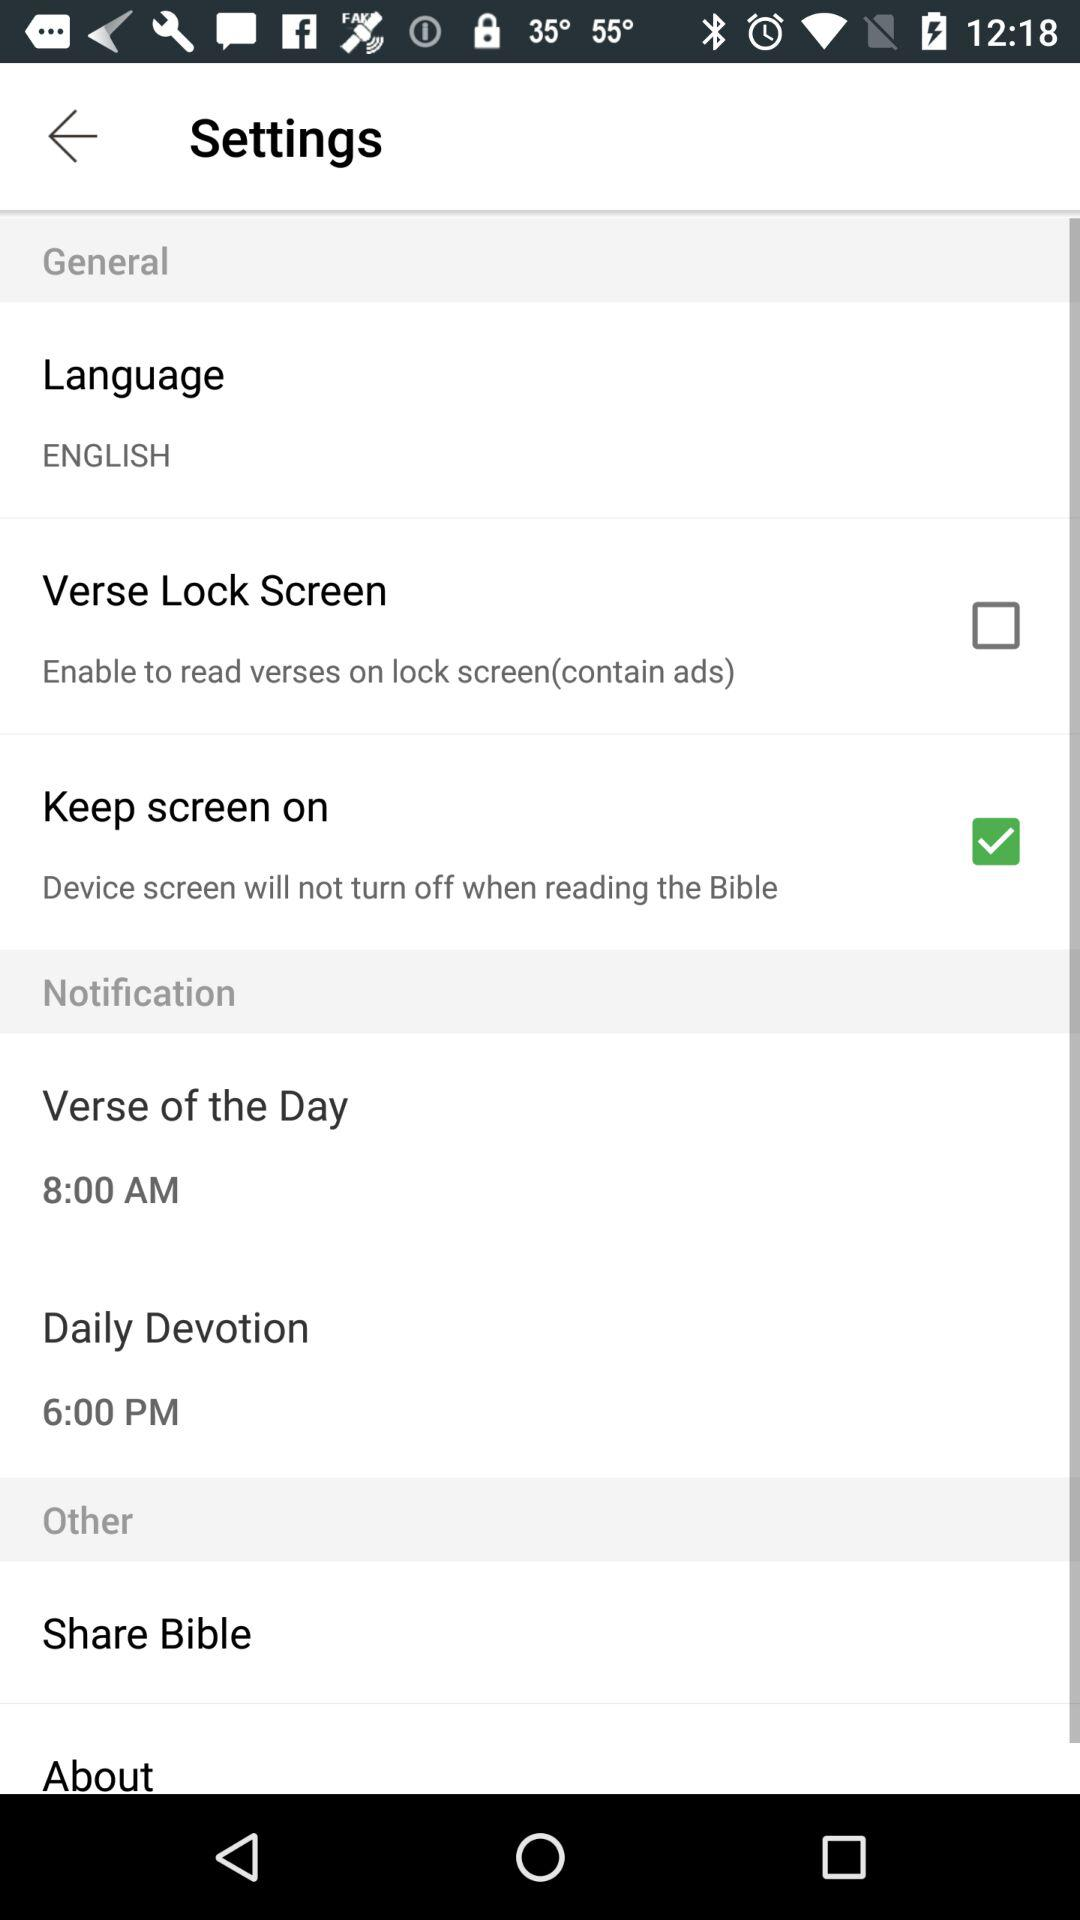What is the time set for the verse of the day? The time set for the verse of the day is 8:00 AM. 